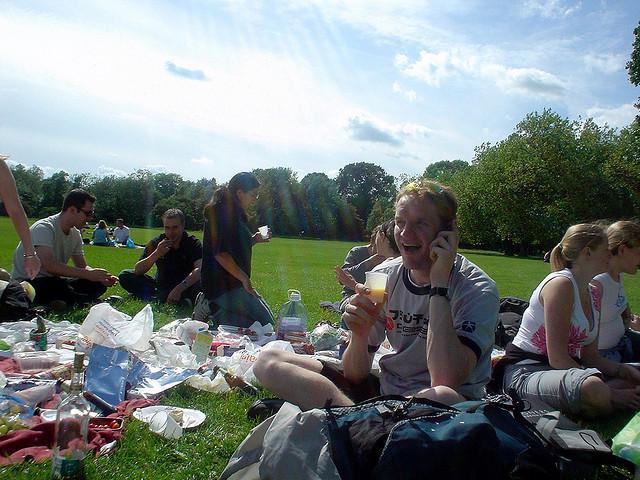How many bottles are there?
Give a very brief answer. 1. How many people are in the photo?
Give a very brief answer. 6. 